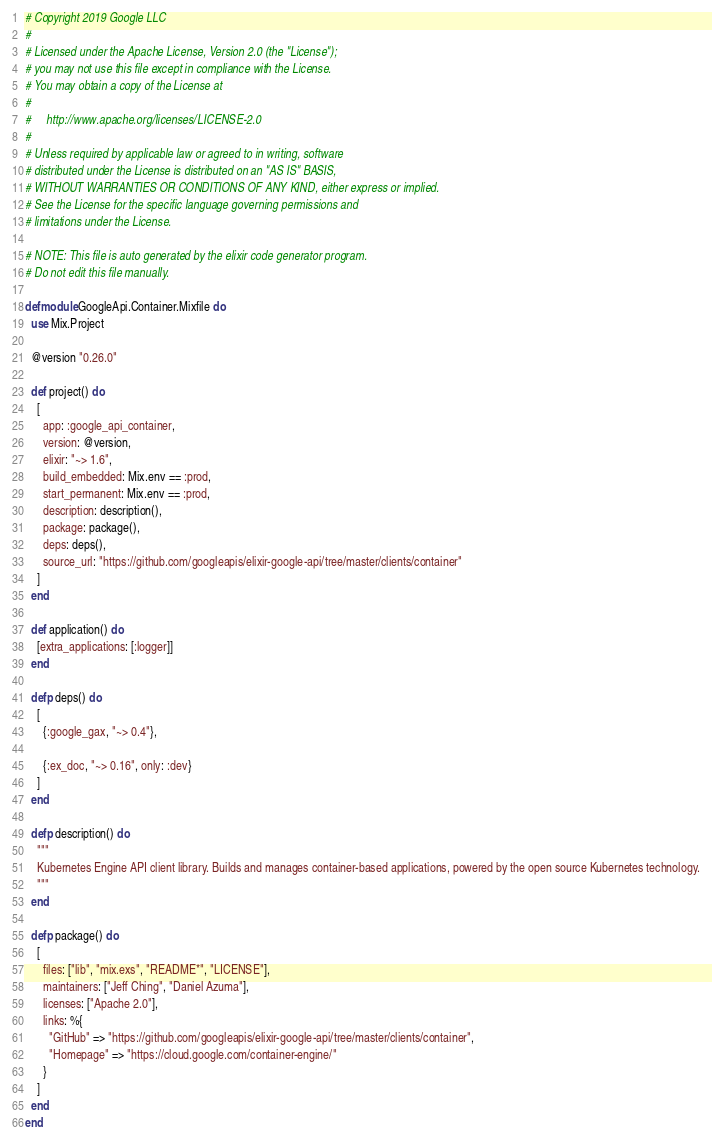<code> <loc_0><loc_0><loc_500><loc_500><_Elixir_># Copyright 2019 Google LLC
#
# Licensed under the Apache License, Version 2.0 (the "License");
# you may not use this file except in compliance with the License.
# You may obtain a copy of the License at
#
#     http://www.apache.org/licenses/LICENSE-2.0
#
# Unless required by applicable law or agreed to in writing, software
# distributed under the License is distributed on an "AS IS" BASIS,
# WITHOUT WARRANTIES OR CONDITIONS OF ANY KIND, either express or implied.
# See the License for the specific language governing permissions and
# limitations under the License.

# NOTE: This file is auto generated by the elixir code generator program.
# Do not edit this file manually.

defmodule GoogleApi.Container.Mixfile do
  use Mix.Project

  @version "0.26.0"

  def project() do
    [
      app: :google_api_container,
      version: @version,
      elixir: "~> 1.6",
      build_embedded: Mix.env == :prod,
      start_permanent: Mix.env == :prod,
      description: description(),
      package: package(),
      deps: deps(),
      source_url: "https://github.com/googleapis/elixir-google-api/tree/master/clients/container"
    ]
  end

  def application() do
    [extra_applications: [:logger]]
  end

  defp deps() do
    [
      {:google_gax, "~> 0.4"},

      {:ex_doc, "~> 0.16", only: :dev}
    ]
  end

  defp description() do
    """
    Kubernetes Engine API client library. Builds and manages container-based applications, powered by the open source Kubernetes technology.
    """
  end

  defp package() do
    [
      files: ["lib", "mix.exs", "README*", "LICENSE"],
      maintainers: ["Jeff Ching", "Daniel Azuma"],
      licenses: ["Apache 2.0"],
      links: %{
        "GitHub" => "https://github.com/googleapis/elixir-google-api/tree/master/clients/container",
        "Homepage" => "https://cloud.google.com/container-engine/"
      }
    ]
  end
end
</code> 